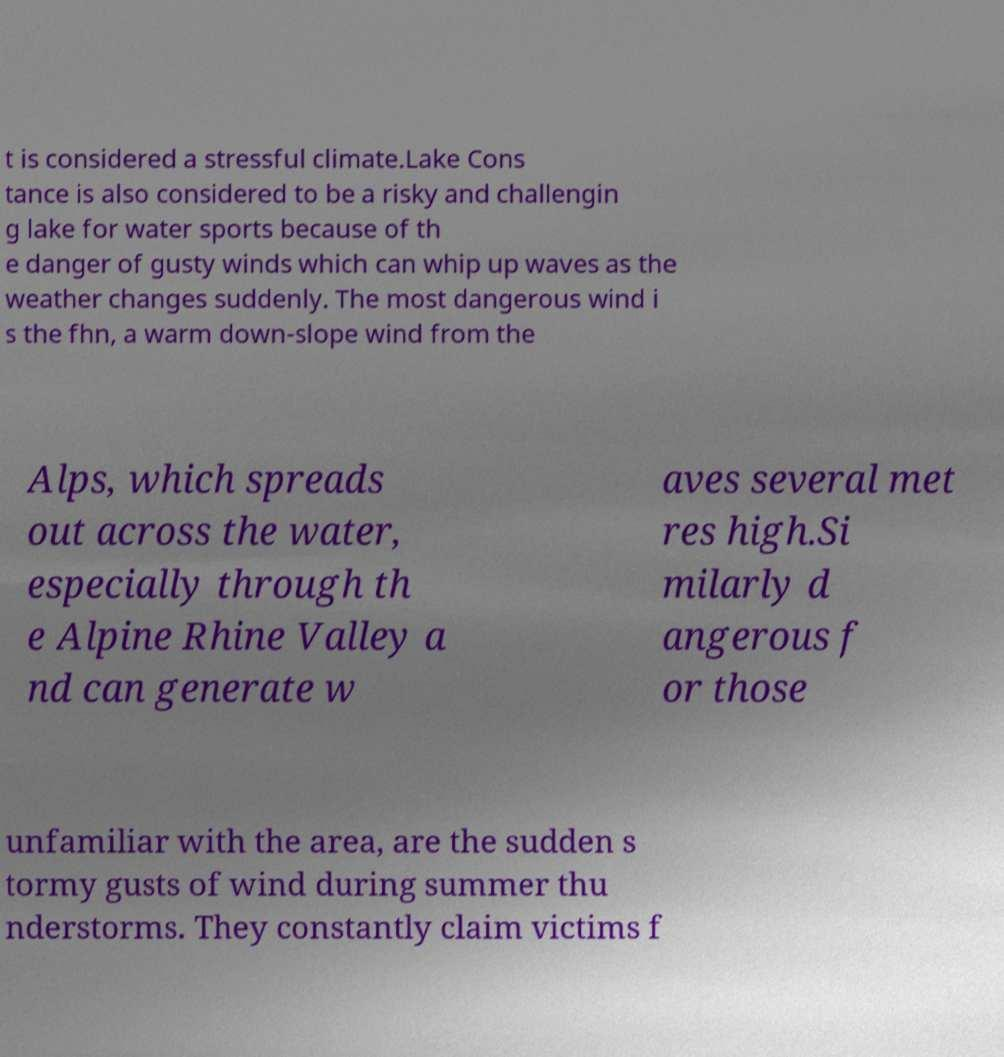Can you accurately transcribe the text from the provided image for me? t is considered a stressful climate.Lake Cons tance is also considered to be a risky and challengin g lake for water sports because of th e danger of gusty winds which can whip up waves as the weather changes suddenly. The most dangerous wind i s the fhn, a warm down-slope wind from the Alps, which spreads out across the water, especially through th e Alpine Rhine Valley a nd can generate w aves several met res high.Si milarly d angerous f or those unfamiliar with the area, are the sudden s tormy gusts of wind during summer thu nderstorms. They constantly claim victims f 